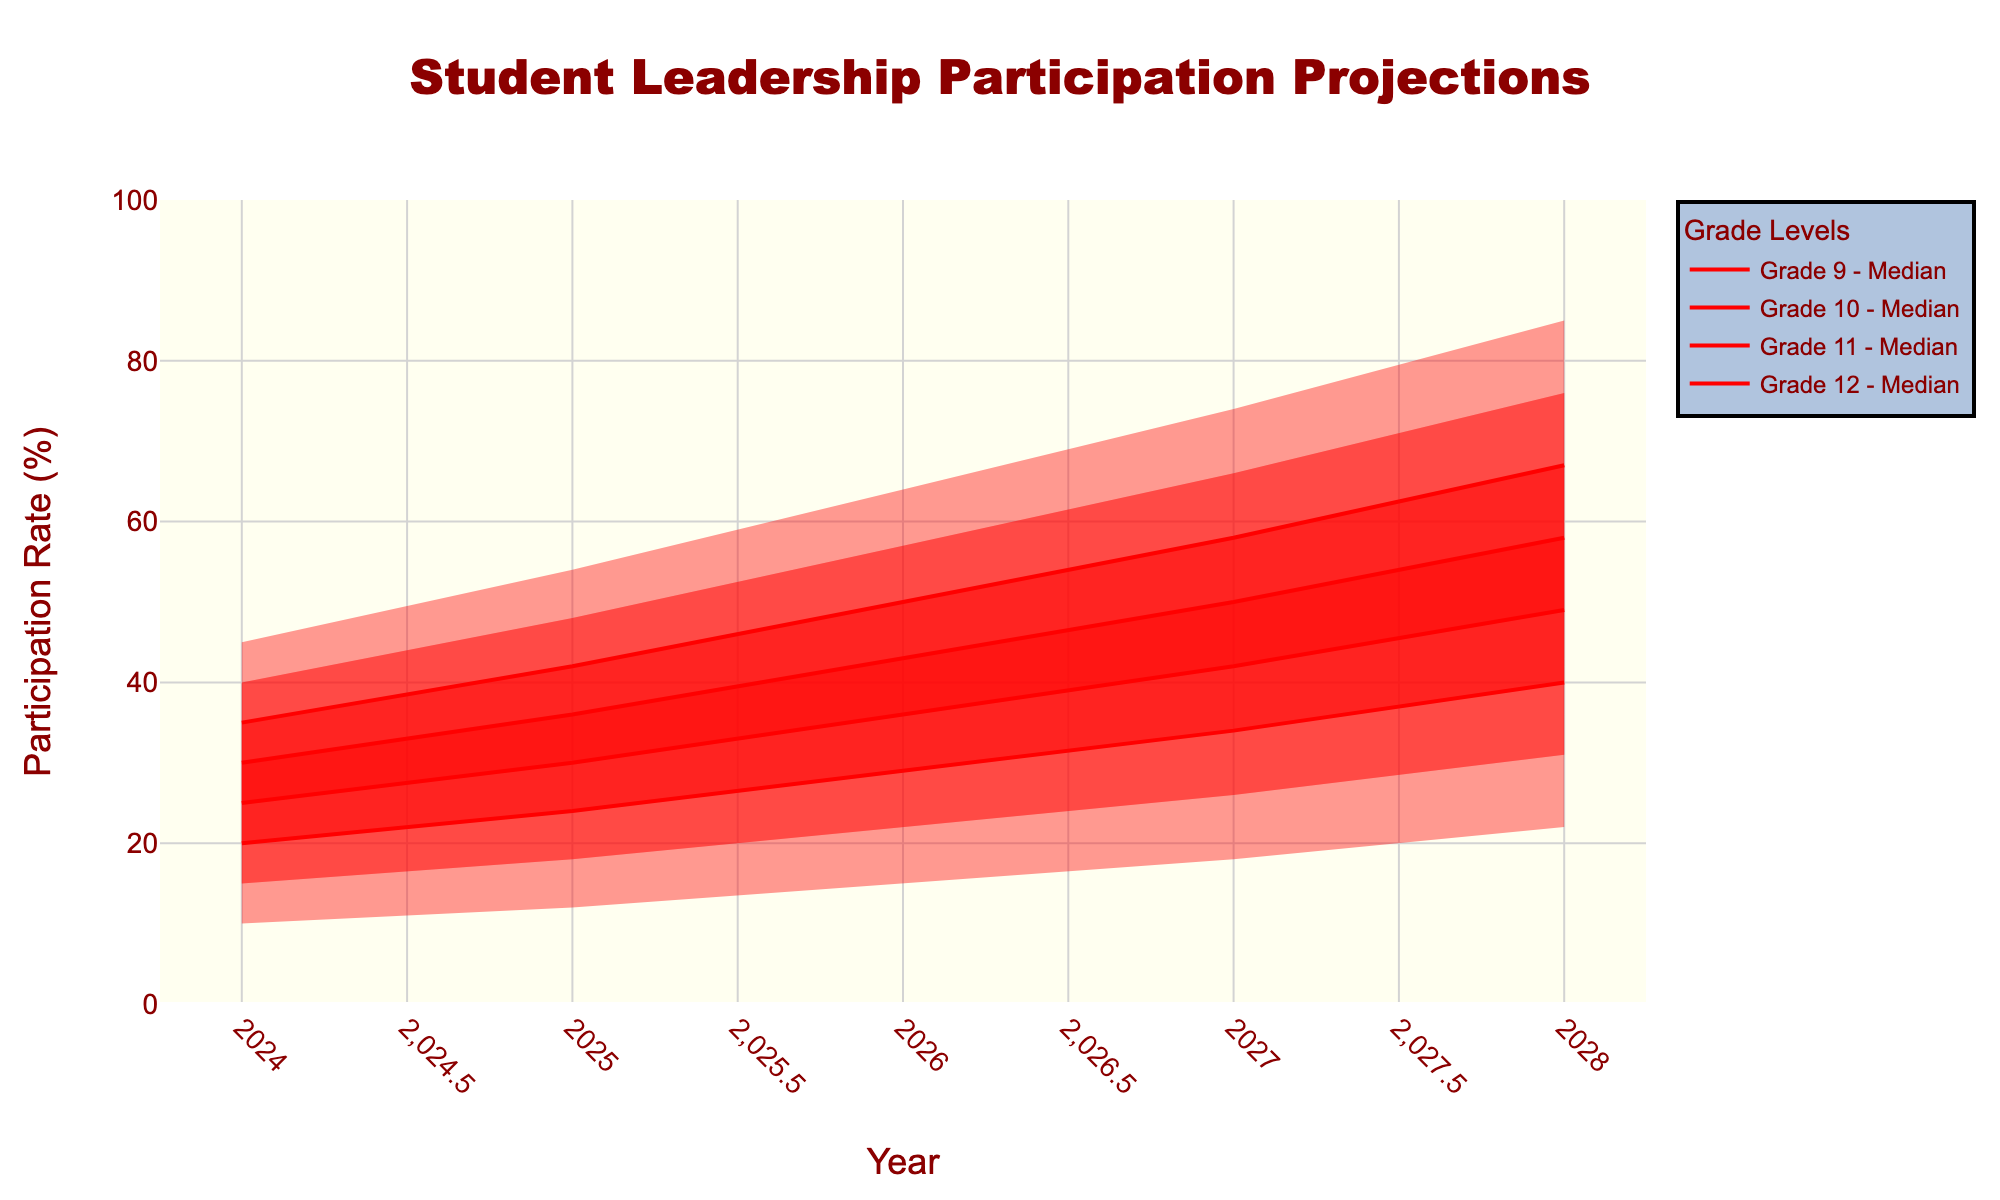How does the projected participation rate for 9th grade in 2028 compare to the median participation rate in 2024? In 2028, the median participation rate for 9th grade is projected to be 40%. In 2024, the median participation rate for 9th grade is 20%. By comparing these two values, we can see that the projected participation rate in 2028 is twice as high as it was in 2024.
Answer: The projected participation rate for 9th grade in 2028 is twice as high as in 2024 Which grade level has the highest projected median participation rate in 2027? To determine the grade with the highest projected median participation rate in 2027, we need to look at the median participation values for each grade in 2027. The medians are as follows: 9th grade - 34%, 10th grade - 42%, 11th grade - 50%, and 12th grade - 58%. The highest value is for 12th grade.
Answer: 12th grade What is the range of projected participation rates for 10th grade in 2025? The range is the difference between the highest and lowest projected participation rates. For 10th grade in 2025, the highest rate is 42% and the lowest is 18%. Subtracting these, we get 42% - 18% = 24%.
Answer: 24% How much is the participation rate expected to increase for 11th grade from 2024 to 2028 at the median level? The median participation rate for 11th grade in 2024 is 30%, and in 2028 it is 58%. The increase is calculated as: 58% - 30% = 28%.
Answer: 28% Which year is projected to have the highest median participation for 9th grade, and what is that value? By examining the median participation rates over the years for 9th grade, the following values are given: 2024 - 20%, 2025 - 24%, 2026 - 29%, 2027 - 34%, 2028 - 40%. The highest median rate of 40% is projected for 2028.
Answer: 2028, 40% What is the difference between the high and low projections for 12th grade in 2026? For 12th grade in 2026, the high projection is 64% and the low is 36%. The difference is calculated as 64% - 36% = 28%.
Answer: 28% How does the projected participation rate range for 9th grade in 2026 compare to that of 11th grade in the same year? In 2026, the 9th grade participation rate ranges from 15% to 43% (a range of 28%), while the 11th grade ranges from 29% to 57% (a range of 28%). Both grades have the same range of 28%.
Answer: Both ranges are 28% Which grades show more significant growth in their median participation rates from 2024 to 2028, 9th or 10th grade? For 9th grade, the median rate grows from 20% in 2024 to 40% in 2028, an increase of 20%. For 10th grade, the median rate grows from 25% in 2024 to 49% in 2028, an increase of 24%. The 10th grade shows more significant growth.
Answer: 10th grade What is the projected participation range (low to high) for 12th graders in the year 2028? For 12th graders in 2028, the projections range from a low of 49% to a high of 85%.
Answer: 49% to 85% 